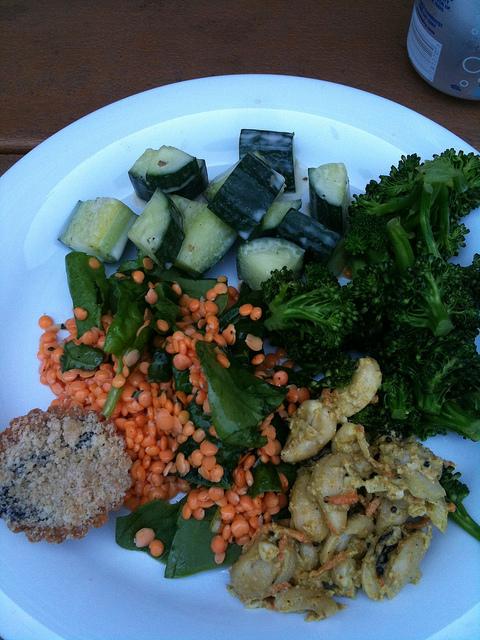What color are the chickpeas?
Keep it brief. Orange. What is orange?
Concise answer only. Beans. What shape is the plate?
Write a very short answer. Round. Are the cucumbers sliced?
Concise answer only. Yes. What is this?
Concise answer only. Food. 